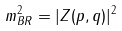Convert formula to latex. <formula><loc_0><loc_0><loc_500><loc_500>m _ { B R } ^ { 2 } = | Z ( p , q ) | ^ { 2 }</formula> 